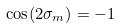<formula> <loc_0><loc_0><loc_500><loc_500>\cos ( 2 \sigma _ { m } ) = - 1</formula> 